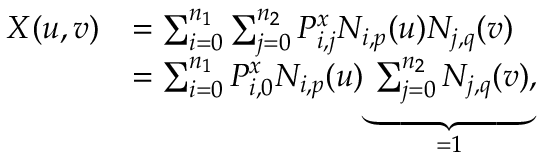<formula> <loc_0><loc_0><loc_500><loc_500>\begin{array} { r l } { X ( u , v ) } & { = \sum _ { i = 0 } ^ { n _ { 1 } } \sum _ { j = 0 } ^ { n _ { 2 } } P _ { i , j } ^ { x } N _ { i , p } ( u ) N _ { j , q } ( v ) } \\ & { = \sum _ { i = 0 } ^ { n _ { 1 } } P _ { i , 0 } ^ { x } N _ { i , p } ( u ) \underbrace { \sum _ { j = 0 } ^ { n _ { 2 } } N _ { j , q } ( v ) } _ { = 1 } , } \end{array}</formula> 